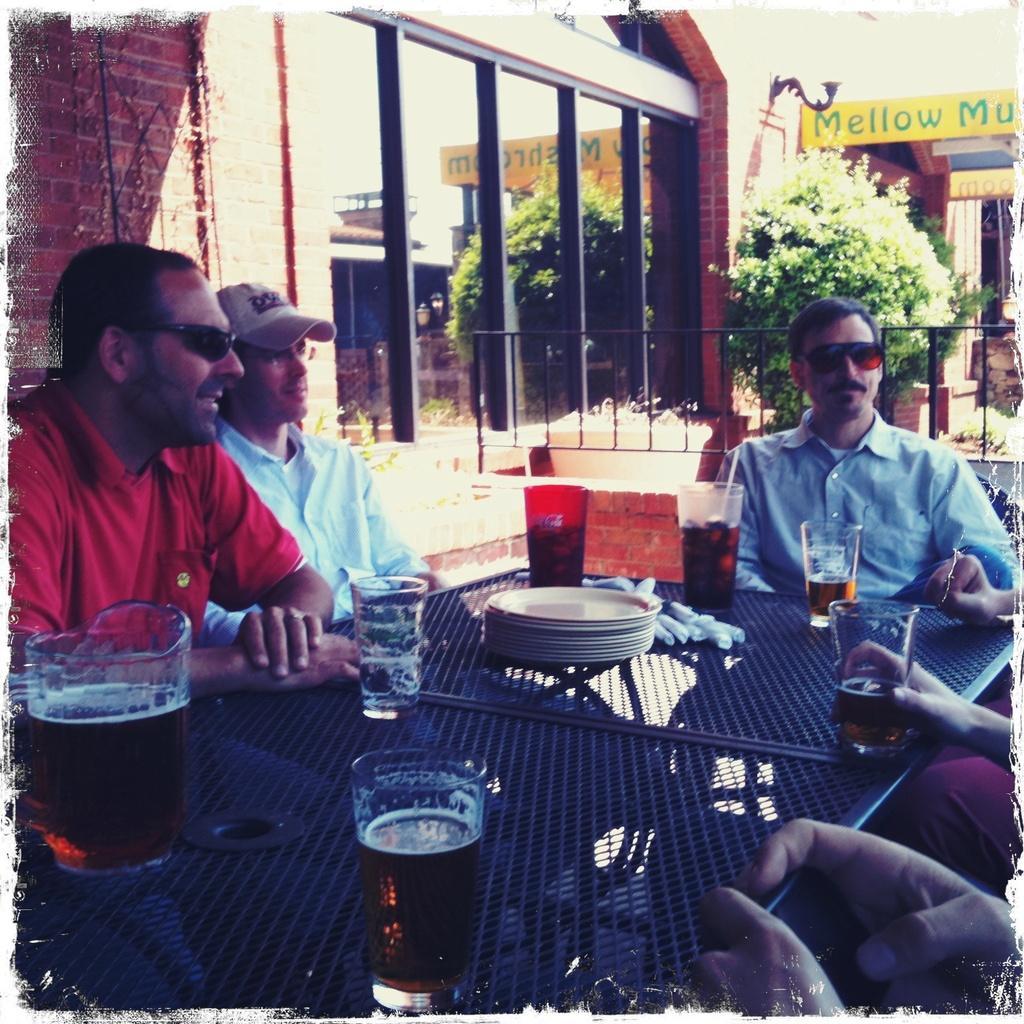Can you describe this image briefly? In this image In the middle there is a table on that there are plates and glasses, around the table there are some people. In the background there is a house, window, glass, plant, wall and text. 